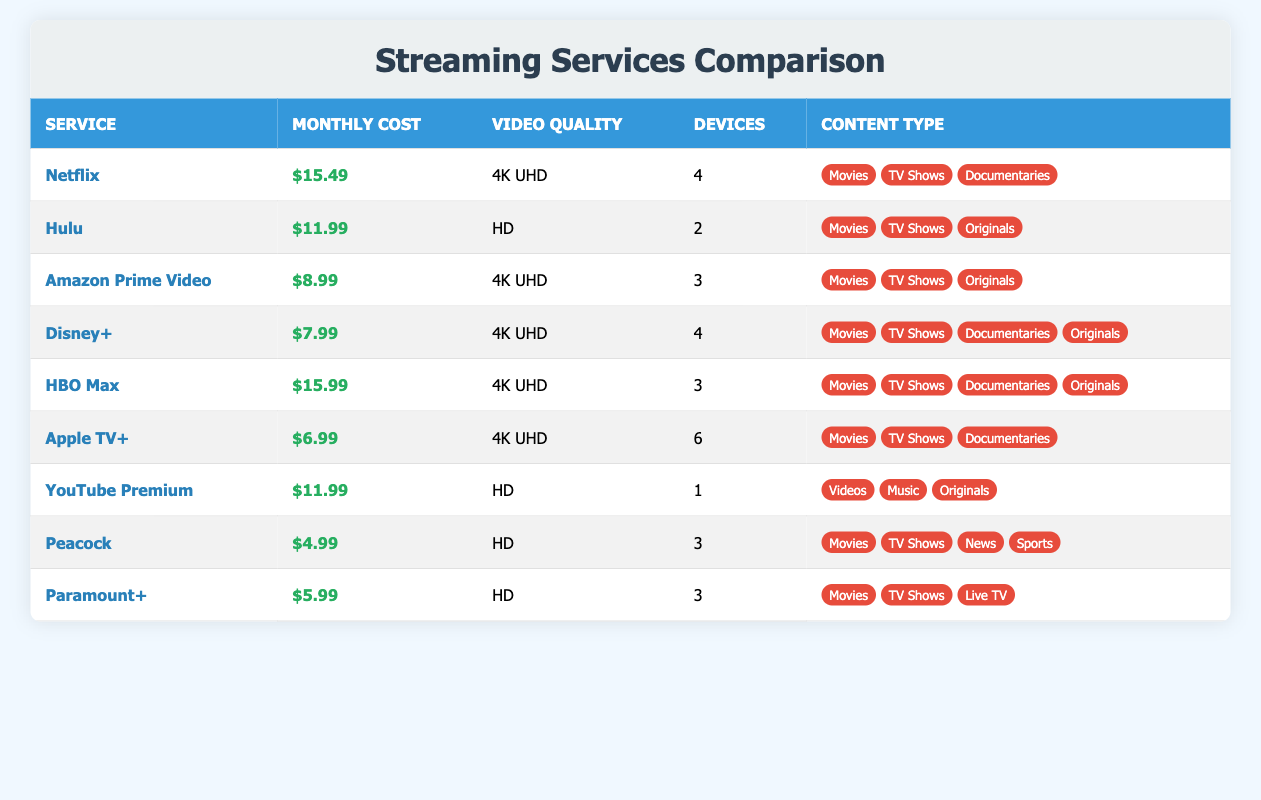What is the monthly cost of Hulu? The table clearly lists Hulu under the "Service" column, and corresponding to that, the "Monthly Cost" column shows $11.99.
Answer: $11.99 Which service allows the maximum number of devices? In the table, we look for the "Devices" column and find Apple TV+ with 6 devices listed, which is the highest among all services.
Answer: Apple TV+ How many services offer 4K UHD video quality? By scanning through the "Video Quality" column, we identify Netflix, Amazon Prime Video, HBO Max, Disney+, and Apple TV+ as services that provide 4K UHD. This totals to 5 services.
Answer: 5 What is the average monthly cost of all streaming services? To find the average cost, we sum all the monthly costs: (15.49 + 11.99 + 8.99 + 7.99 + 15.99 + 6.99 + 11.99 + 4.99 + 5.99) = 83.42. There are 9 services, so the average cost is 83.42 / 9 ≈ 9.27.
Answer: 9.27 Is it true that both YouTube Premium and Hulu have the same monthly cost? Looking at the "Monthly Cost" column, we see that YouTube Premium and Hulu have costs of $11.99 each, confirming that they are the same.
Answer: Yes Which service has the highest monthly cost, and what is it? By examining the "Monthly Cost" column, HBO Max shows the highest cost of $15.99, thus answering the question for both service and price.
Answer: HBO Max, $15.99 How much less does Paramount+ cost compared to Netflix? Checking the "Monthly Cost" for Paramount+ ($5.99) and Netflix ($15.49), the difference is $15.49 - $5.99 = $9.50, indicating a clear savings with Paramount+.
Answer: $9.50 Are there any services that provide both documentaries and originals? Reviewing the content types, we notice that HBO Max and Disney+ both list "Documentaries" and "Originals" as part of their offerings.
Answer: Yes What type of content does Peacock offer? Looking at the "Content Type" for Peacock, it shows Movies, TV Shows, News, and Sports, indicating a diverse offering in both entertainment and information.
Answer: Movies, TV Shows, News, Sports 